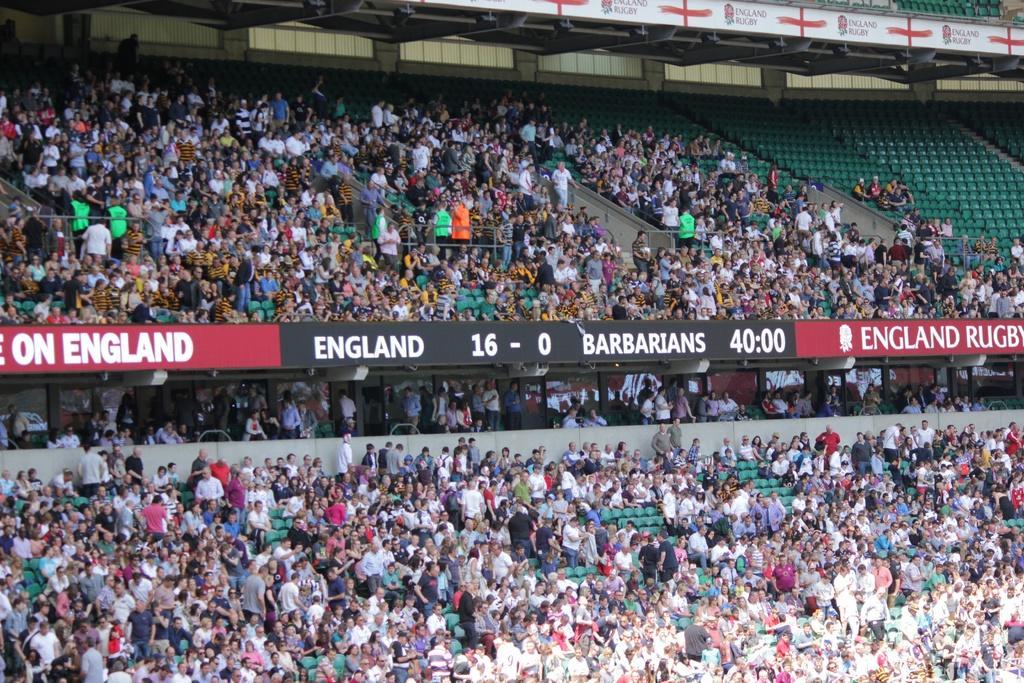Please provide a concise description of this image. In this image we can see a stadium. There are two digital boards in the image. There are many people in the image. There are vacant chairs at the right top most of the image. 